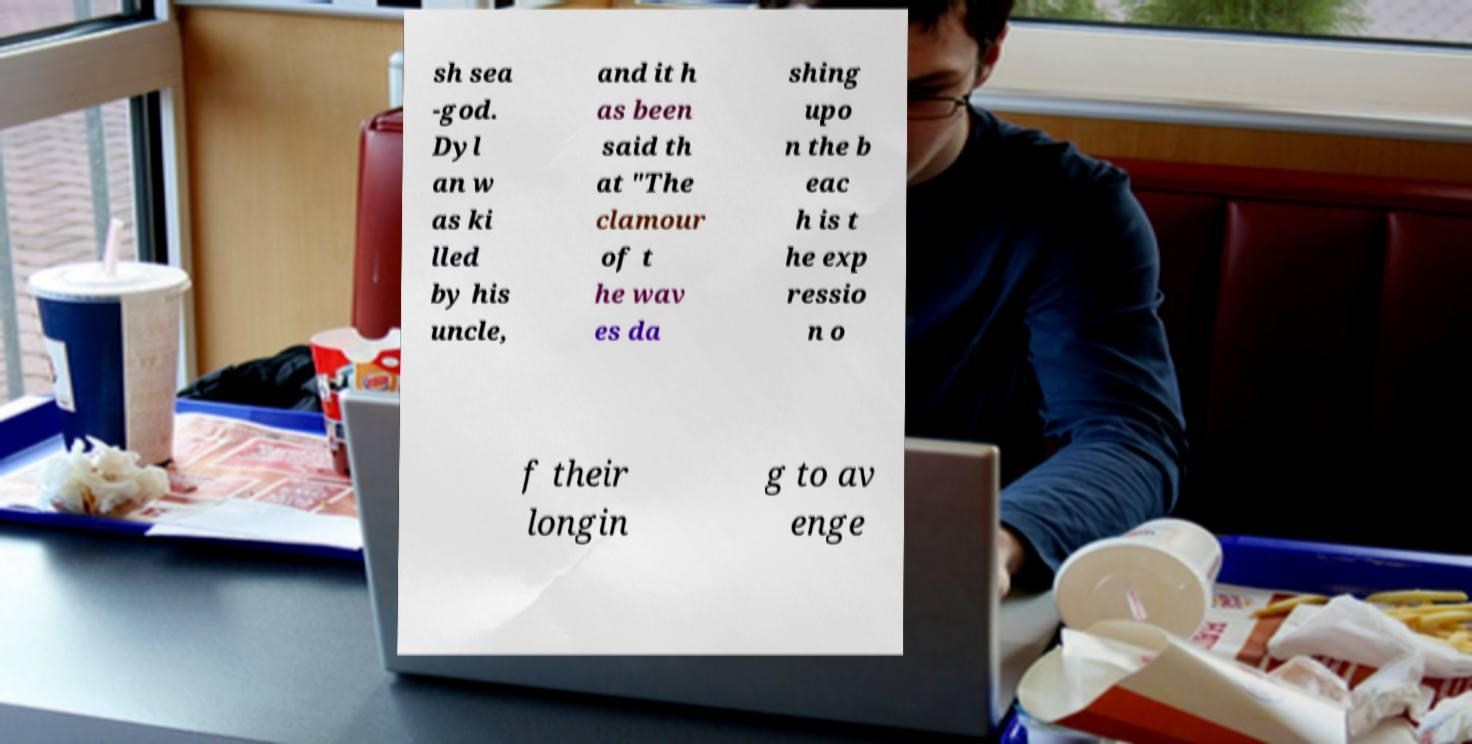Please identify and transcribe the text found in this image. sh sea -god. Dyl an w as ki lled by his uncle, and it h as been said th at "The clamour of t he wav es da shing upo n the b eac h is t he exp ressio n o f their longin g to av enge 